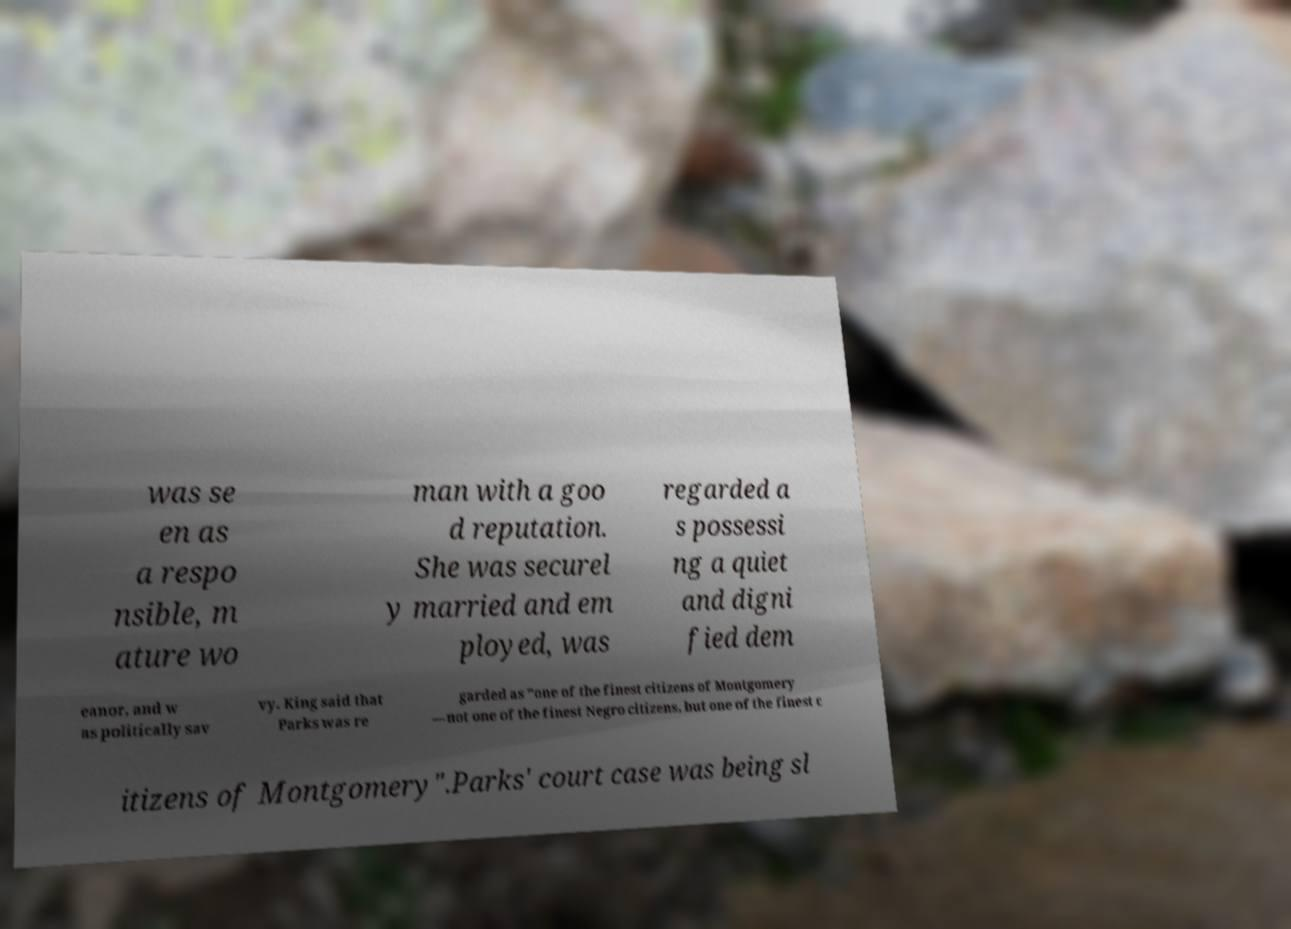Can you read and provide the text displayed in the image?This photo seems to have some interesting text. Can you extract and type it out for me? was se en as a respo nsible, m ature wo man with a goo d reputation. She was securel y married and em ployed, was regarded a s possessi ng a quiet and digni fied dem eanor, and w as politically sav vy. King said that Parks was re garded as "one of the finest citizens of Montgomery —not one of the finest Negro citizens, but one of the finest c itizens of Montgomery".Parks' court case was being sl 